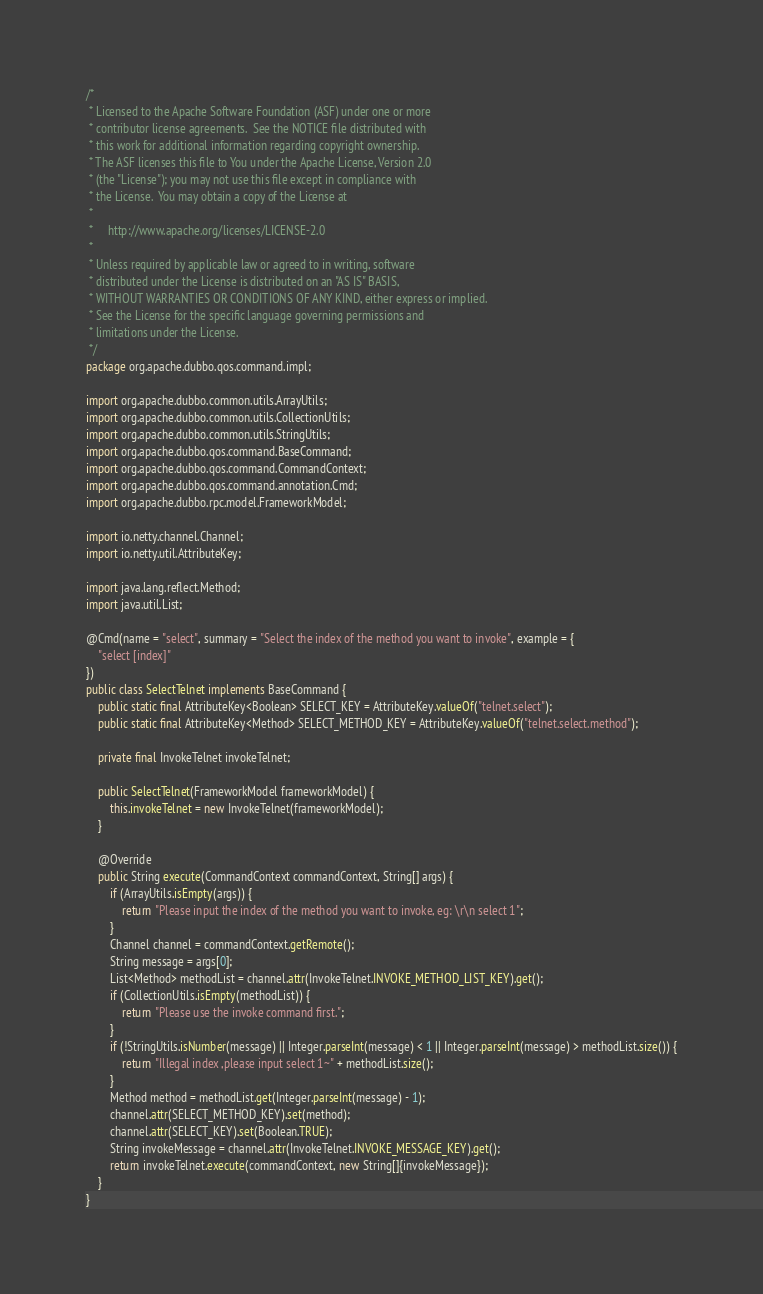Convert code to text. <code><loc_0><loc_0><loc_500><loc_500><_Java_>/*
 * Licensed to the Apache Software Foundation (ASF) under one or more
 * contributor license agreements.  See the NOTICE file distributed with
 * this work for additional information regarding copyright ownership.
 * The ASF licenses this file to You under the Apache License, Version 2.0
 * (the "License"); you may not use this file except in compliance with
 * the License.  You may obtain a copy of the License at
 *
 *     http://www.apache.org/licenses/LICENSE-2.0
 *
 * Unless required by applicable law or agreed to in writing, software
 * distributed under the License is distributed on an "AS IS" BASIS,
 * WITHOUT WARRANTIES OR CONDITIONS OF ANY KIND, either express or implied.
 * See the License for the specific language governing permissions and
 * limitations under the License.
 */
package org.apache.dubbo.qos.command.impl;

import org.apache.dubbo.common.utils.ArrayUtils;
import org.apache.dubbo.common.utils.CollectionUtils;
import org.apache.dubbo.common.utils.StringUtils;
import org.apache.dubbo.qos.command.BaseCommand;
import org.apache.dubbo.qos.command.CommandContext;
import org.apache.dubbo.qos.command.annotation.Cmd;
import org.apache.dubbo.rpc.model.FrameworkModel;

import io.netty.channel.Channel;
import io.netty.util.AttributeKey;

import java.lang.reflect.Method;
import java.util.List;

@Cmd(name = "select", summary = "Select the index of the method you want to invoke", example = {
    "select [index]"
})
public class SelectTelnet implements BaseCommand {
    public static final AttributeKey<Boolean> SELECT_KEY = AttributeKey.valueOf("telnet.select");
    public static final AttributeKey<Method> SELECT_METHOD_KEY = AttributeKey.valueOf("telnet.select.method");

    private final InvokeTelnet invokeTelnet;

    public SelectTelnet(FrameworkModel frameworkModel) {
        this.invokeTelnet = new InvokeTelnet(frameworkModel);
    }

    @Override
    public String execute(CommandContext commandContext, String[] args) {
        if (ArrayUtils.isEmpty(args)) {
            return "Please input the index of the method you want to invoke, eg: \r\n select 1";
        }
        Channel channel = commandContext.getRemote();
        String message = args[0];
        List<Method> methodList = channel.attr(InvokeTelnet.INVOKE_METHOD_LIST_KEY).get();
        if (CollectionUtils.isEmpty(methodList)) {
            return "Please use the invoke command first.";
        }
        if (!StringUtils.isNumber(message) || Integer.parseInt(message) < 1 || Integer.parseInt(message) > methodList.size()) {
            return "Illegal index ,please input select 1~" + methodList.size();
        }
        Method method = methodList.get(Integer.parseInt(message) - 1);
        channel.attr(SELECT_METHOD_KEY).set(method);
        channel.attr(SELECT_KEY).set(Boolean.TRUE);
        String invokeMessage = channel.attr(InvokeTelnet.INVOKE_MESSAGE_KEY).get();
        return invokeTelnet.execute(commandContext, new String[]{invokeMessage});
    }
}
</code> 